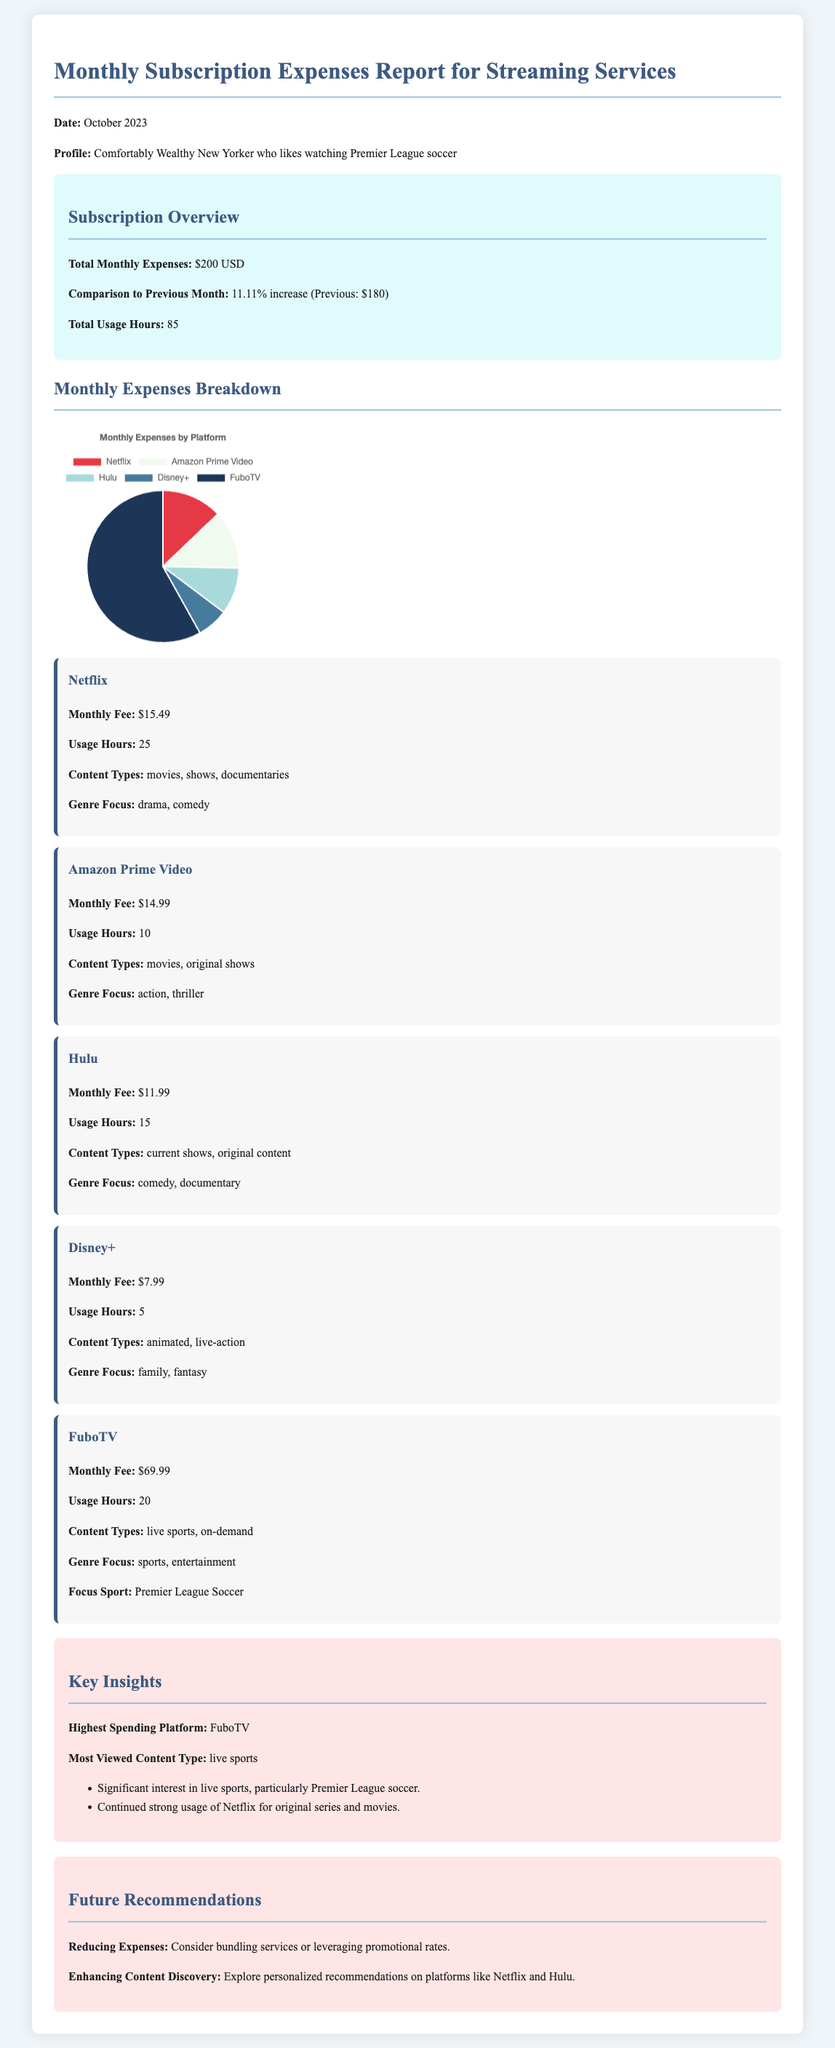What is the total monthly expense? The total monthly expenses reported in the document is immediately stated in the overview section.
Answer: $200 USD What platform has the highest monthly fee? The document provides a breakdown of monthly fees by platform, indicating the highest fee.
Answer: FuboTV How many hours were spent on Netflix? The usage hours for Netflix is specified in the platform's section.
Answer: 25 What was the percentage increase in expenses compared to the previous month? The report compares this month's expenses to last month's, giving a specific percentage.
Answer: 11.11% What genres are primarily focused on Hulu? The document lists the genre focus under the Hulu section.
Answer: comedy, documentary How many total usage hours were reported across all platforms? The total usage hours is summarized in the overview section of the report.
Answer: 85 What is a recommendation for reducing expenses mentioned in the report? The recommendations section provides advice on managing costs effectively.
Answer: Consider bundling services Which type of content is noted as the most viewed? Key insights point to the content type that received the most attention.
Answer: live sports What was the monthly fee for Amazon Prime Video? The document explicitly states the monthly fee associated with Amazon Prime Video.
Answer: $14.99 